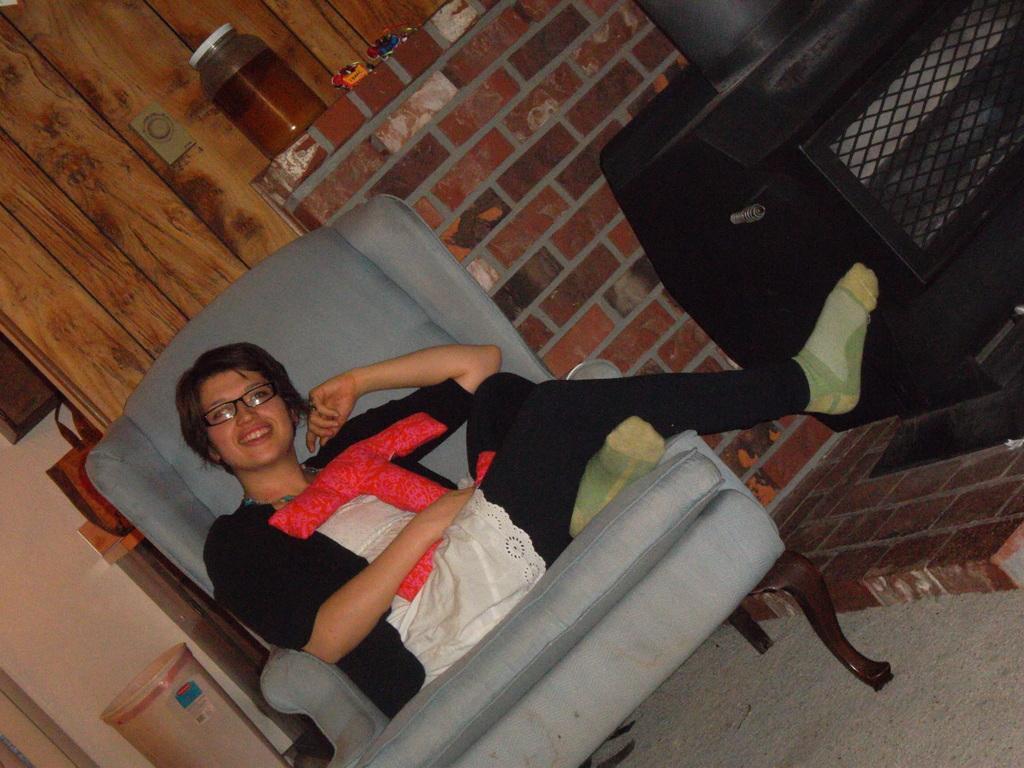Can you describe this image briefly? In this image there is a person sitting on a chair. Beside her there is a black color object. And at back side there are toys and a cupboard. And there is a bag and a basket. And at the back there is a wall. 